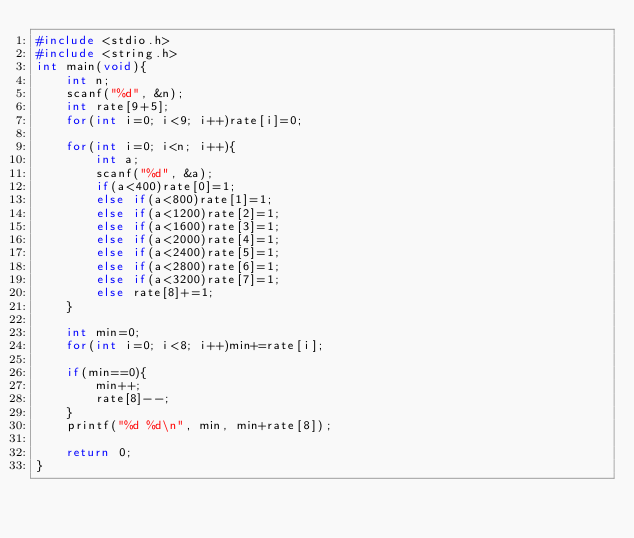<code> <loc_0><loc_0><loc_500><loc_500><_C_>#include <stdio.h>
#include <string.h>
int main(void){
    int n;
    scanf("%d", &n);
    int rate[9+5];
    for(int i=0; i<9; i++)rate[i]=0;
    
    for(int i=0; i<n; i++){
        int a;
        scanf("%d", &a);
        if(a<400)rate[0]=1;
        else if(a<800)rate[1]=1;
        else if(a<1200)rate[2]=1;
        else if(a<1600)rate[3]=1;
        else if(a<2000)rate[4]=1;
        else if(a<2400)rate[5]=1;
        else if(a<2800)rate[6]=1;
        else if(a<3200)rate[7]=1;
        else rate[8]+=1;
    }
    
    int min=0;
    for(int i=0; i<8; i++)min+=rate[i];
    
    if(min==0){
        min++;
        rate[8]--;
    }
    printf("%d %d\n", min, min+rate[8]);
    
    return 0;
}
</code> 